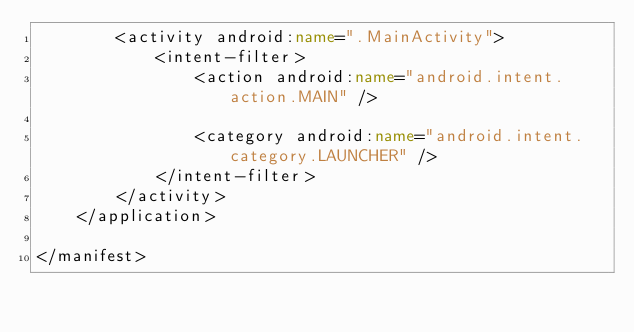Convert code to text. <code><loc_0><loc_0><loc_500><loc_500><_XML_>        <activity android:name=".MainActivity">
            <intent-filter>
                <action android:name="android.intent.action.MAIN" />

                <category android:name="android.intent.category.LAUNCHER" />
            </intent-filter>
        </activity>
    </application>

</manifest></code> 